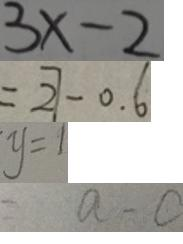<formula> <loc_0><loc_0><loc_500><loc_500>3 x - 2 
 = 2 7 - 0 . 6 
 y = 1 
 = a - c</formula> 